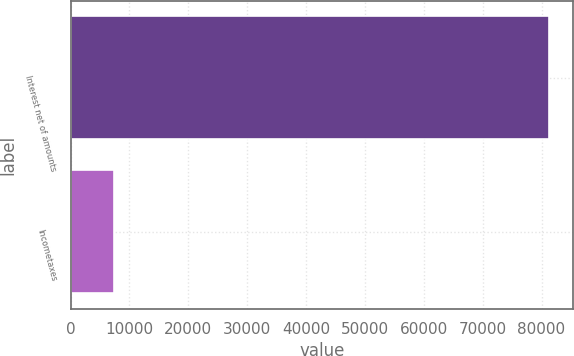<chart> <loc_0><loc_0><loc_500><loc_500><bar_chart><fcel>Interest net of amounts<fcel>Incometaxes<nl><fcel>81303<fcel>7309<nl></chart> 